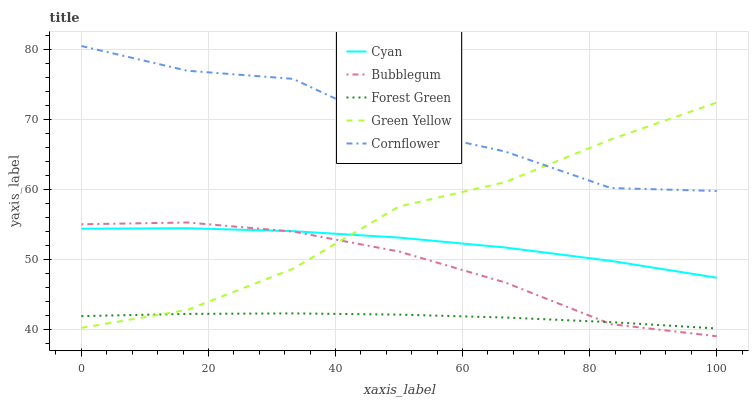Does Forest Green have the minimum area under the curve?
Answer yes or no. Yes. Does Cornflower have the maximum area under the curve?
Answer yes or no. Yes. Does Green Yellow have the minimum area under the curve?
Answer yes or no. No. Does Green Yellow have the maximum area under the curve?
Answer yes or no. No. Is Forest Green the smoothest?
Answer yes or no. Yes. Is Cornflower the roughest?
Answer yes or no. Yes. Is Green Yellow the smoothest?
Answer yes or no. No. Is Green Yellow the roughest?
Answer yes or no. No. Does Bubblegum have the lowest value?
Answer yes or no. Yes. Does Forest Green have the lowest value?
Answer yes or no. No. Does Cornflower have the highest value?
Answer yes or no. Yes. Does Green Yellow have the highest value?
Answer yes or no. No. Is Cyan less than Cornflower?
Answer yes or no. Yes. Is Cornflower greater than Cyan?
Answer yes or no. Yes. Does Cyan intersect Green Yellow?
Answer yes or no. Yes. Is Cyan less than Green Yellow?
Answer yes or no. No. Is Cyan greater than Green Yellow?
Answer yes or no. No. Does Cyan intersect Cornflower?
Answer yes or no. No. 